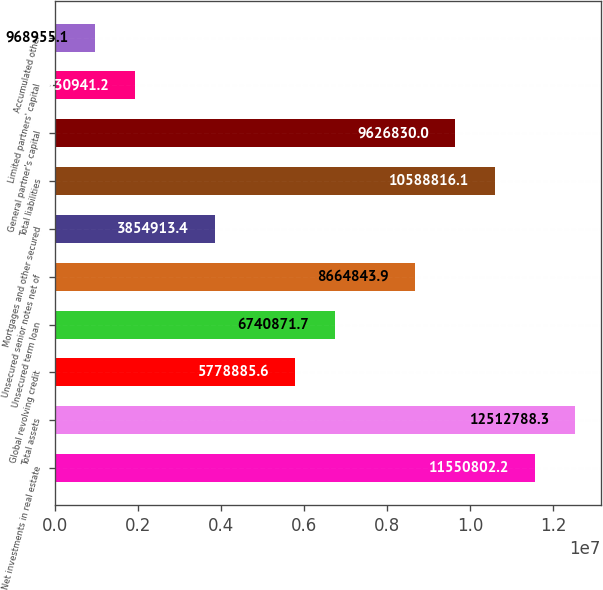<chart> <loc_0><loc_0><loc_500><loc_500><bar_chart><fcel>Net investments in real estate<fcel>Total assets<fcel>Global revolving credit<fcel>Unsecured term loan<fcel>Unsecured senior notes net of<fcel>Mortgages and other secured<fcel>Total liabilities<fcel>General partner's capital<fcel>Limited partners' capital<fcel>Accumulated other<nl><fcel>1.15508e+07<fcel>1.25128e+07<fcel>5.77889e+06<fcel>6.74087e+06<fcel>8.66484e+06<fcel>3.85491e+06<fcel>1.05888e+07<fcel>9.62683e+06<fcel>1.93094e+06<fcel>968955<nl></chart> 